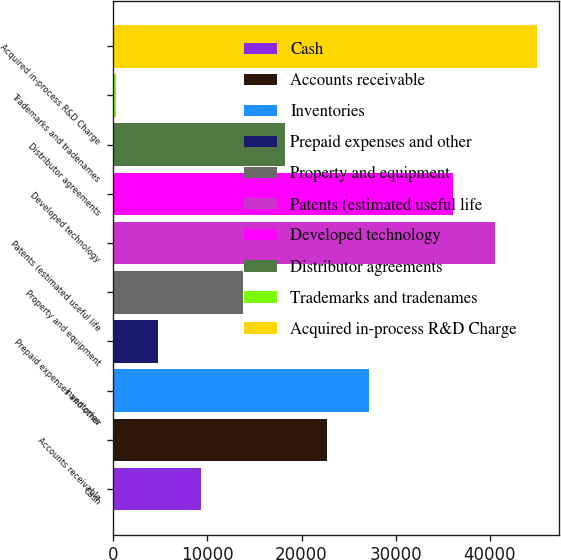Convert chart to OTSL. <chart><loc_0><loc_0><loc_500><loc_500><bar_chart><fcel>Cash<fcel>Accounts receivable<fcel>Inventories<fcel>Prepaid expenses and other<fcel>Property and equipment<fcel>Patents (estimated useful life<fcel>Developed technology<fcel>Distributor agreements<fcel>Trademarks and tradenames<fcel>Acquired in-process R&D Charge<nl><fcel>9265.4<fcel>22692.5<fcel>27168.2<fcel>4789.7<fcel>13741.1<fcel>40595.3<fcel>36119.6<fcel>18216.8<fcel>314<fcel>45071<nl></chart> 